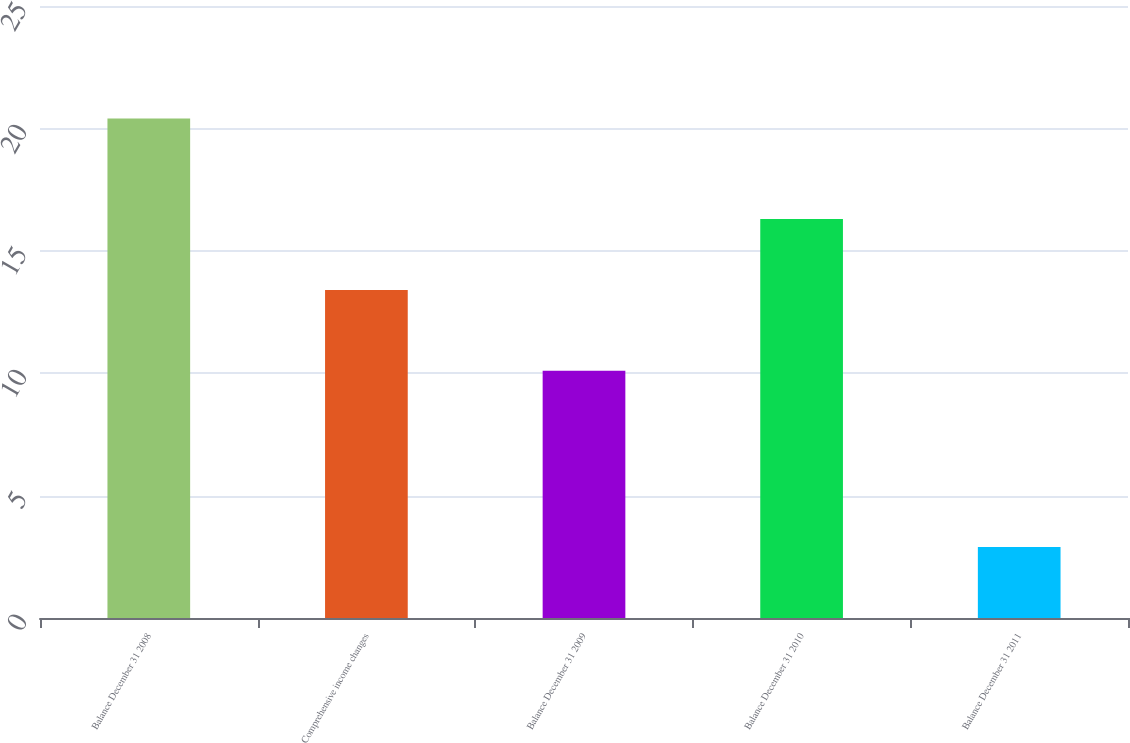Convert chart to OTSL. <chart><loc_0><loc_0><loc_500><loc_500><bar_chart><fcel>Balance December 31 2008<fcel>Comprehensive income changes<fcel>Balance December 31 2009<fcel>Balance December 31 2010<fcel>Balance December 31 2011<nl><fcel>20.4<fcel>13.4<fcel>10.1<fcel>16.3<fcel>2.9<nl></chart> 